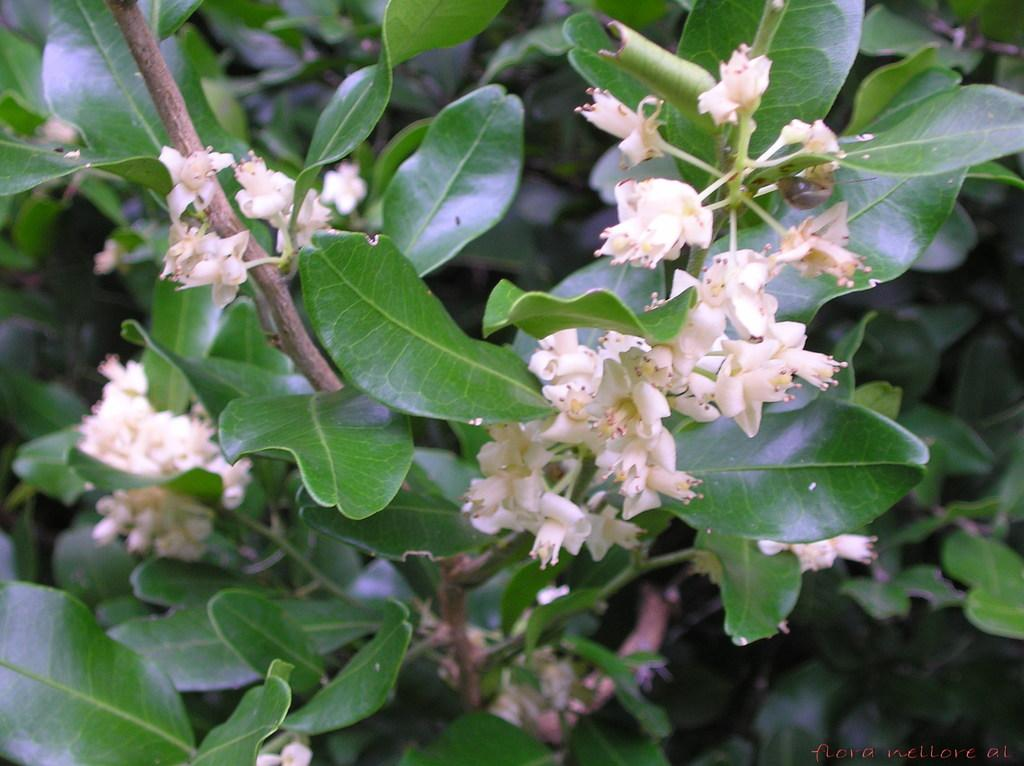What types of plants are visible in the image? There are flowers and plants visible in the image. What else can be seen in the image besides plants? There is text visible in the image. Based on the lighting and colors in the image, when might it have been taken? The image was likely taken during the day. Where might this image have been taken, considering the types of plants present? The image may have been taken in a garden. What type of disease is being treated by the lawyer in the image? There is no lawyer or disease present in the image; it features flowers, plants, and text. 